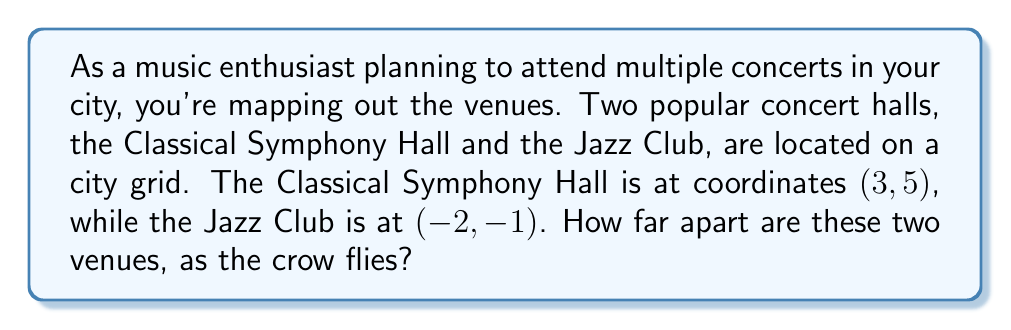Can you answer this question? To find the distance between two points on a coordinate plane, we use the distance formula, which is derived from the Pythagorean theorem:

$$ d = \sqrt{(x_2 - x_1)^2 + (y_2 - y_1)^2} $$

Where $(x_1, y_1)$ are the coordinates of the first point and $(x_2, y_2)$ are the coordinates of the second point.

Let's assign our points:
- Classical Symphony Hall: $(x_1, y_1) = (3, 5)$
- Jazz Club: $(x_2, y_2) = (-2, -1)$

Now, let's plug these into our formula:

$$ d = \sqrt{(-2 - 3)^2 + (-1 - 5)^2} $$

Simplify inside the parentheses:
$$ d = \sqrt{(-5)^2 + (-6)^2} $$

Calculate the squares:
$$ d = \sqrt{25 + 36} $$

Add inside the square root:
$$ d = \sqrt{61} $$

This gives us the exact distance. If we want to approximate:
$$ d \approx 7.81 $$

So, the distance between the two venues is $\sqrt{61}$ units, or approximately 7.81 units on the city grid.
Answer: $\sqrt{61}$ units (approximately 7.81 units) 